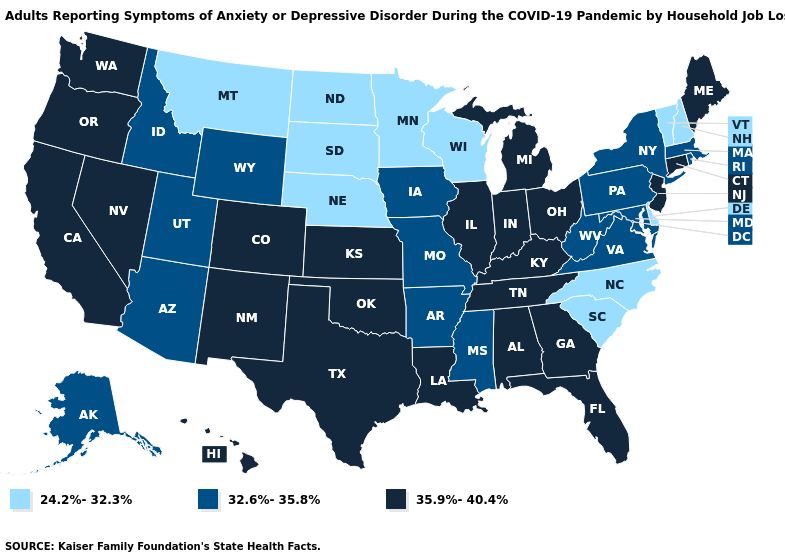Does the first symbol in the legend represent the smallest category?
Concise answer only. Yes. What is the value of Utah?
Keep it brief. 32.6%-35.8%. Name the states that have a value in the range 32.6%-35.8%?
Write a very short answer. Alaska, Arizona, Arkansas, Idaho, Iowa, Maryland, Massachusetts, Mississippi, Missouri, New York, Pennsylvania, Rhode Island, Utah, Virginia, West Virginia, Wyoming. Name the states that have a value in the range 32.6%-35.8%?
Concise answer only. Alaska, Arizona, Arkansas, Idaho, Iowa, Maryland, Massachusetts, Mississippi, Missouri, New York, Pennsylvania, Rhode Island, Utah, Virginia, West Virginia, Wyoming. Does Minnesota have the lowest value in the USA?
Answer briefly. Yes. Which states hav the highest value in the Northeast?
Be succinct. Connecticut, Maine, New Jersey. Is the legend a continuous bar?
Short answer required. No. Which states have the highest value in the USA?
Write a very short answer. Alabama, California, Colorado, Connecticut, Florida, Georgia, Hawaii, Illinois, Indiana, Kansas, Kentucky, Louisiana, Maine, Michigan, Nevada, New Jersey, New Mexico, Ohio, Oklahoma, Oregon, Tennessee, Texas, Washington. Name the states that have a value in the range 24.2%-32.3%?
Quick response, please. Delaware, Minnesota, Montana, Nebraska, New Hampshire, North Carolina, North Dakota, South Carolina, South Dakota, Vermont, Wisconsin. What is the value of Oklahoma?
Give a very brief answer. 35.9%-40.4%. Which states hav the highest value in the West?
Write a very short answer. California, Colorado, Hawaii, Nevada, New Mexico, Oregon, Washington. Name the states that have a value in the range 24.2%-32.3%?
Write a very short answer. Delaware, Minnesota, Montana, Nebraska, New Hampshire, North Carolina, North Dakota, South Carolina, South Dakota, Vermont, Wisconsin. Does Montana have a lower value than Minnesota?
Answer briefly. No. What is the highest value in states that border Georgia?
Concise answer only. 35.9%-40.4%. 